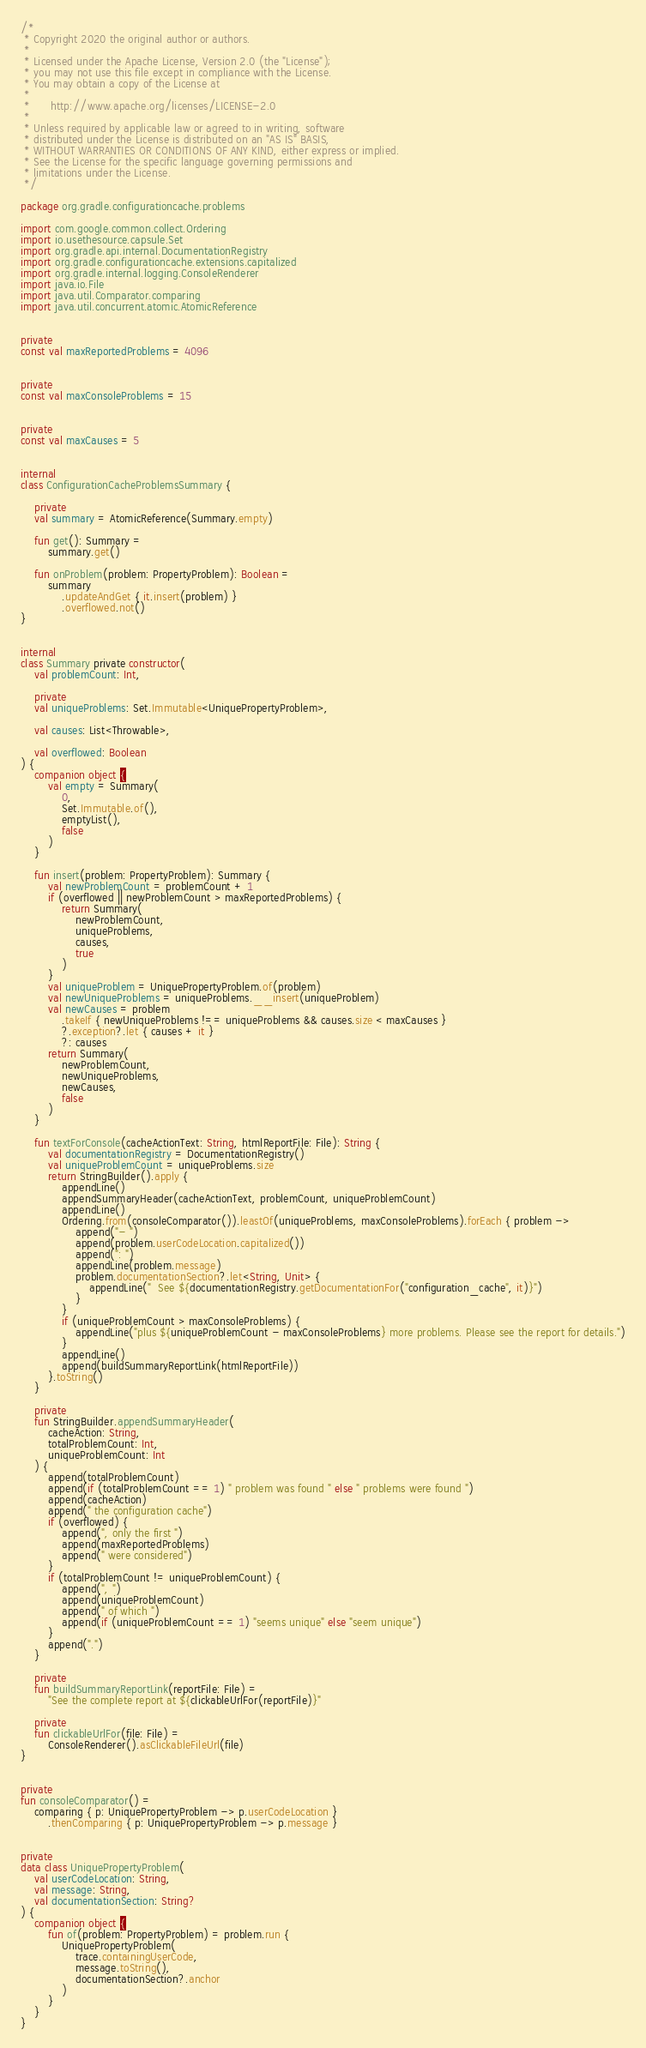<code> <loc_0><loc_0><loc_500><loc_500><_Kotlin_>/*
 * Copyright 2020 the original author or authors.
 *
 * Licensed under the Apache License, Version 2.0 (the "License");
 * you may not use this file except in compliance with the License.
 * You may obtain a copy of the License at
 *
 *      http://www.apache.org/licenses/LICENSE-2.0
 *
 * Unless required by applicable law or agreed to in writing, software
 * distributed under the License is distributed on an "AS IS" BASIS,
 * WITHOUT WARRANTIES OR CONDITIONS OF ANY KIND, either express or implied.
 * See the License for the specific language governing permissions and
 * limitations under the License.
 */

package org.gradle.configurationcache.problems

import com.google.common.collect.Ordering
import io.usethesource.capsule.Set
import org.gradle.api.internal.DocumentationRegistry
import org.gradle.configurationcache.extensions.capitalized
import org.gradle.internal.logging.ConsoleRenderer
import java.io.File
import java.util.Comparator.comparing
import java.util.concurrent.atomic.AtomicReference


private
const val maxReportedProblems = 4096


private
const val maxConsoleProblems = 15


private
const val maxCauses = 5


internal
class ConfigurationCacheProblemsSummary {

    private
    val summary = AtomicReference(Summary.empty)

    fun get(): Summary =
        summary.get()

    fun onProblem(problem: PropertyProblem): Boolean =
        summary
            .updateAndGet { it.insert(problem) }
            .overflowed.not()
}


internal
class Summary private constructor(
    val problemCount: Int,

    private
    val uniqueProblems: Set.Immutable<UniquePropertyProblem>,

    val causes: List<Throwable>,

    val overflowed: Boolean
) {
    companion object {
        val empty = Summary(
            0,
            Set.Immutable.of(),
            emptyList(),
            false
        )
    }

    fun insert(problem: PropertyProblem): Summary {
        val newProblemCount = problemCount + 1
        if (overflowed || newProblemCount > maxReportedProblems) {
            return Summary(
                newProblemCount,
                uniqueProblems,
                causes,
                true
            )
        }
        val uniqueProblem = UniquePropertyProblem.of(problem)
        val newUniqueProblems = uniqueProblems.__insert(uniqueProblem)
        val newCauses = problem
            .takeIf { newUniqueProblems !== uniqueProblems && causes.size < maxCauses }
            ?.exception?.let { causes + it }
            ?: causes
        return Summary(
            newProblemCount,
            newUniqueProblems,
            newCauses,
            false
        )
    }

    fun textForConsole(cacheActionText: String, htmlReportFile: File): String {
        val documentationRegistry = DocumentationRegistry()
        val uniqueProblemCount = uniqueProblems.size
        return StringBuilder().apply {
            appendLine()
            appendSummaryHeader(cacheActionText, problemCount, uniqueProblemCount)
            appendLine()
            Ordering.from(consoleComparator()).leastOf(uniqueProblems, maxConsoleProblems).forEach { problem ->
                append("- ")
                append(problem.userCodeLocation.capitalized())
                append(": ")
                appendLine(problem.message)
                problem.documentationSection?.let<String, Unit> {
                    appendLine("  See ${documentationRegistry.getDocumentationFor("configuration_cache", it)}")
                }
            }
            if (uniqueProblemCount > maxConsoleProblems) {
                appendLine("plus ${uniqueProblemCount - maxConsoleProblems} more problems. Please see the report for details.")
            }
            appendLine()
            append(buildSummaryReportLink(htmlReportFile))
        }.toString()
    }

    private
    fun StringBuilder.appendSummaryHeader(
        cacheAction: String,
        totalProblemCount: Int,
        uniqueProblemCount: Int
    ) {
        append(totalProblemCount)
        append(if (totalProblemCount == 1) " problem was found " else " problems were found ")
        append(cacheAction)
        append(" the configuration cache")
        if (overflowed) {
            append(", only the first ")
            append(maxReportedProblems)
            append(" were considered")
        }
        if (totalProblemCount != uniqueProblemCount) {
            append(", ")
            append(uniqueProblemCount)
            append(" of which ")
            append(if (uniqueProblemCount == 1) "seems unique" else "seem unique")
        }
        append(".")
    }

    private
    fun buildSummaryReportLink(reportFile: File) =
        "See the complete report at ${clickableUrlFor(reportFile)}"

    private
    fun clickableUrlFor(file: File) =
        ConsoleRenderer().asClickableFileUrl(file)
}


private
fun consoleComparator() =
    comparing { p: UniquePropertyProblem -> p.userCodeLocation }
        .thenComparing { p: UniquePropertyProblem -> p.message }


private
data class UniquePropertyProblem(
    val userCodeLocation: String,
    val message: String,
    val documentationSection: String?
) {
    companion object {
        fun of(problem: PropertyProblem) = problem.run {
            UniquePropertyProblem(
                trace.containingUserCode,
                message.toString(),
                documentationSection?.anchor
            )
        }
    }
}
</code> 